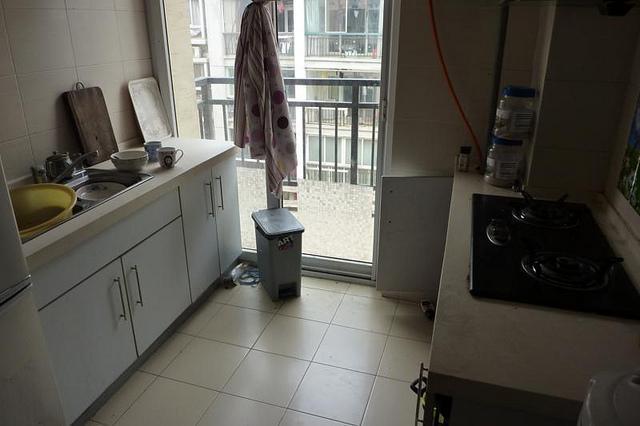In what type of housing complex is this kitchen part of?
From the following set of four choices, select the accurate answer to respond to the question.
Options: University dorm, condominium, apartment, detached home. Apartment. 